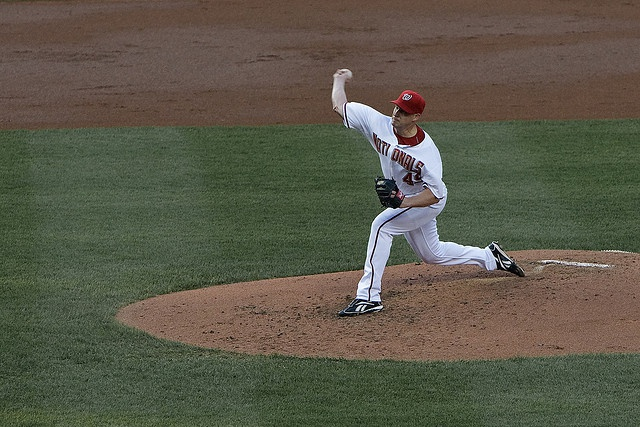Describe the objects in this image and their specific colors. I can see people in black, lavender, gray, and darkgray tones, baseball glove in black, gray, darkgray, and purple tones, and sports ball in black, darkgray, lightgray, and gray tones in this image. 